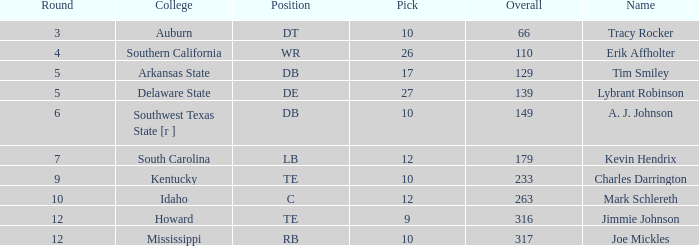What is the sum of Overall, when Name is "Tim Smiley", and when Round is less than 5? None. 